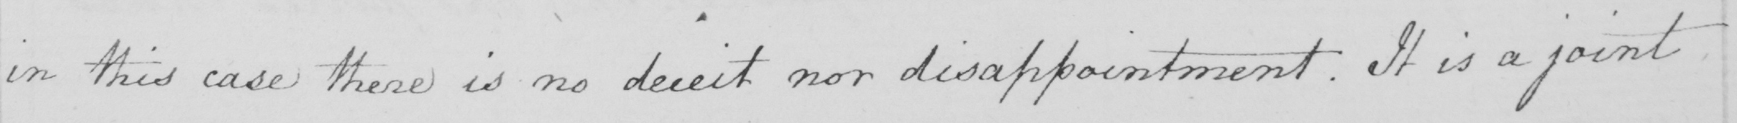Transcribe the text shown in this historical manuscript line. in this case there is no deceit nor disappointment . It is a joint 